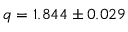<formula> <loc_0><loc_0><loc_500><loc_500>q = 1 . 8 4 4 \pm 0 . 0 2 9</formula> 